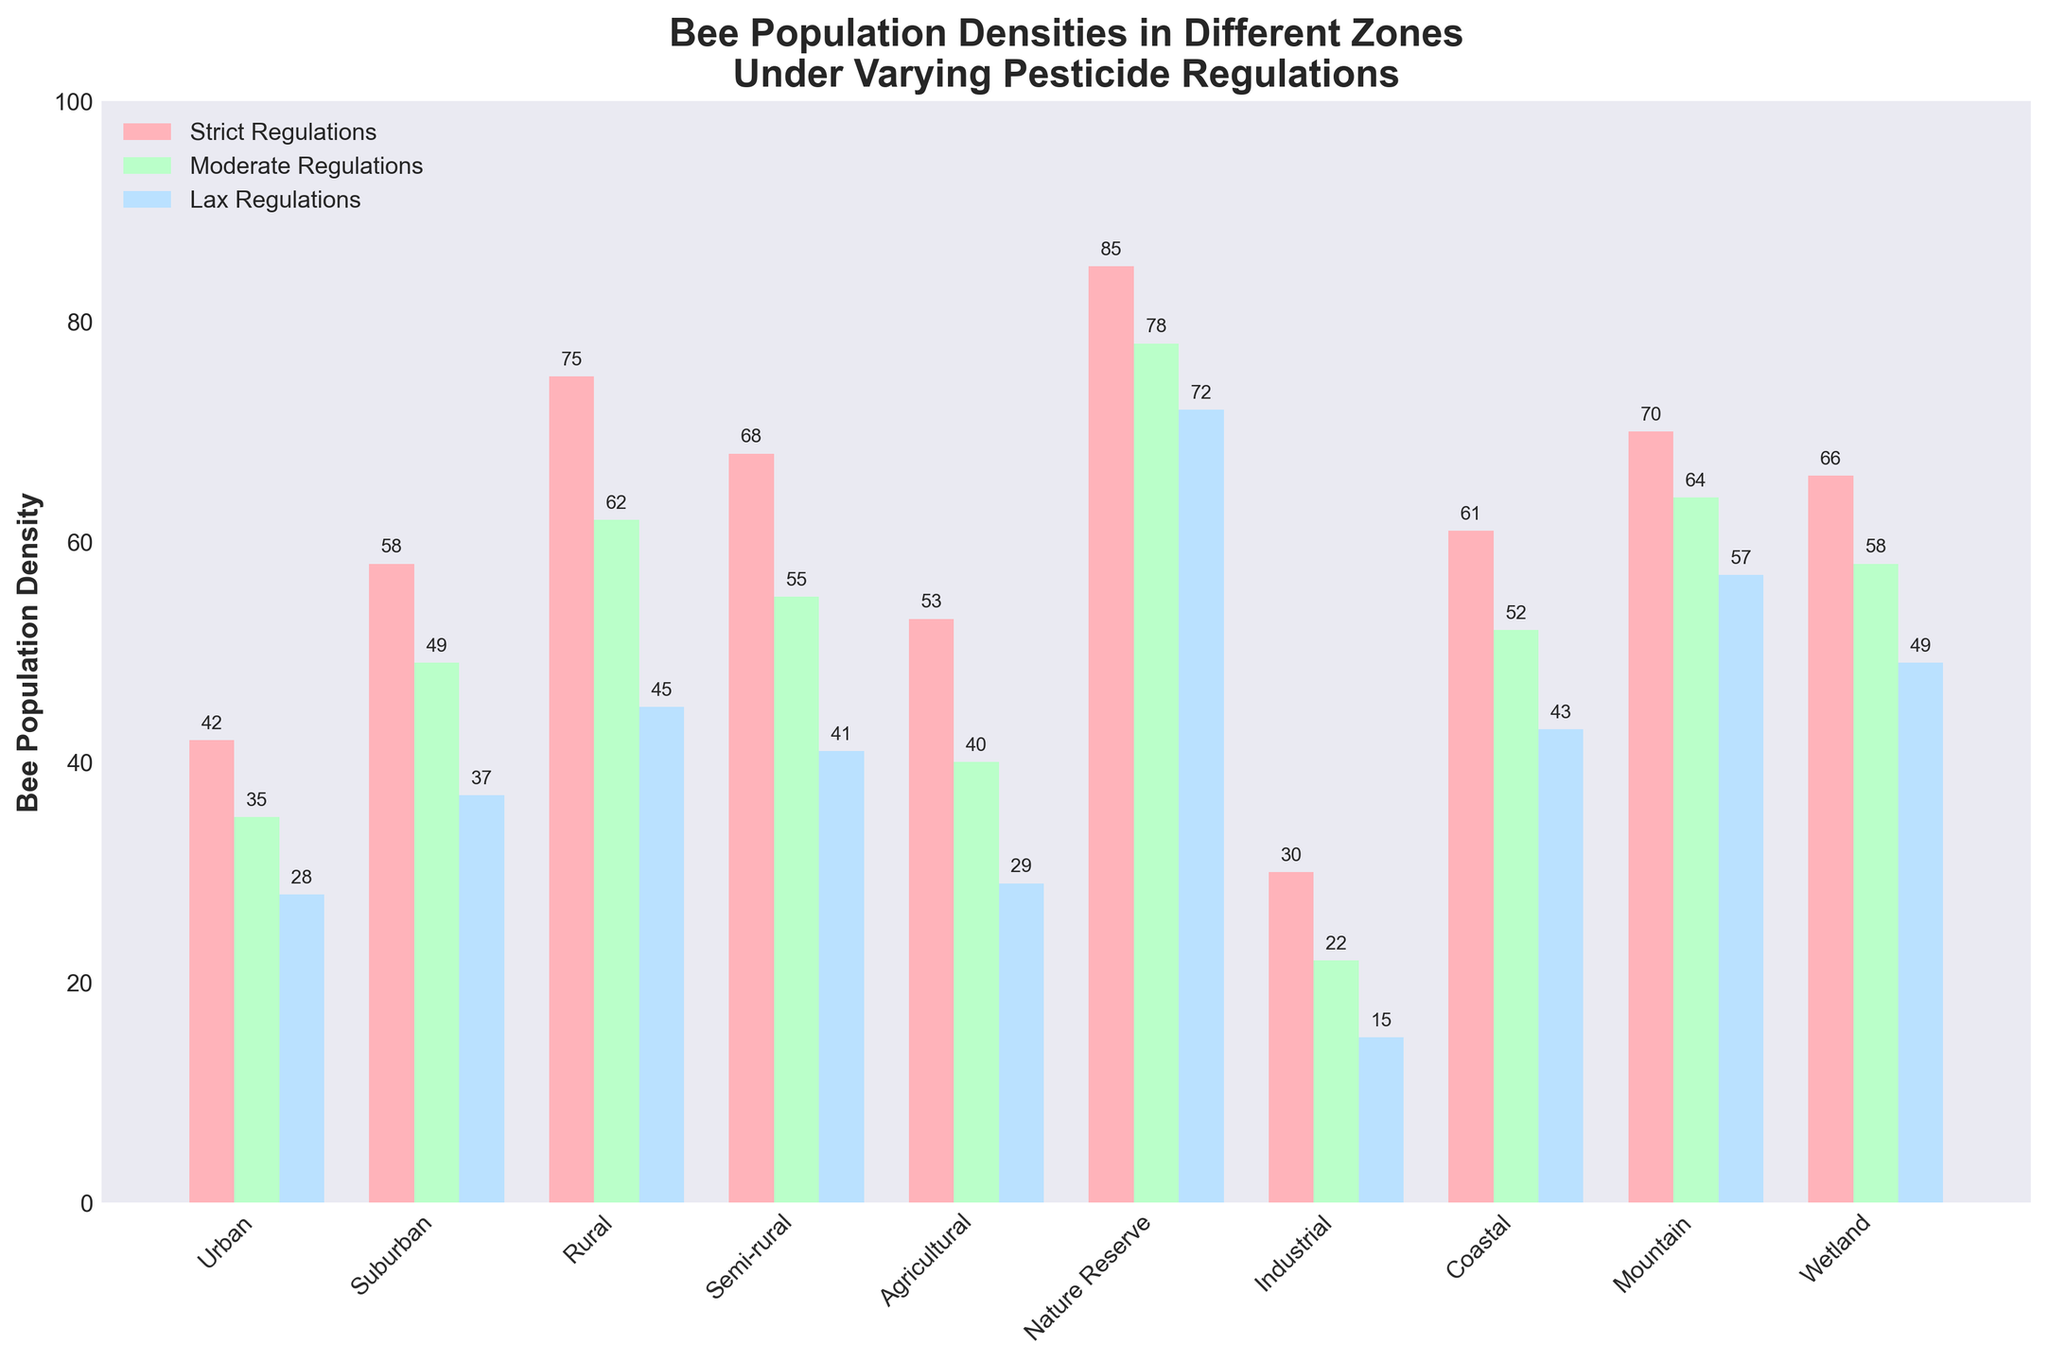What's the highest bee population density among all zones for each regulation level? By examining the bar chart, identify the tallest bars in each of the three categories: Strict Regulations, Moderate Regulations, and Lax Regulations. The highest densities are 85 (Nature Reserve), 78 (Nature Reserve), and 72 (Nature Reserve) respectively.
Answer: 85, 78, 72 Which zone has the lowest bee population density for Lax Regulations? Look at the bars corresponding to Lax Regulations for all zones and find the shortest one. The Industrial zone has the shortest bar, indicating the lowest density.
Answer: Industrial How much higher is the bee population density in Rural zones under Strict Regulations compared to Moderate Regulations? Subtract the bee population density under Moderate Regulations from that under Strict Regulations in Rural zones: 75 (Strict) - 62 (Moderate) = 13.
Answer: 13 Which two zones have almost the same bee population density under Moderate Regulations? Compare the heights of the bars in the Moderate Regulations category and find two zones with similar heights: Mountain and Wetland (64 and 58) are close, but Coastal and Wetland are closest (52 and 49).
Answer: Coastal and Wetland What is the average bee population density for Urban zones across all regulation levels? Sum the densities across the three regulation levels and divide by 3: (42 + 35 + 28) / 3 = 35.
Answer: 35 For which regulation level do Industrial zones have the largest difference in bee population density compared to Nature Reserves? Calculate the difference in bee population density between Nature Reserves and Industrial zones for each regulation level. The differences are 85-30=55 (Strict), 78-22=56 (Moderate), and 72-15=57 (Lax). The largest difference is 57 under Lax Regulations.
Answer: Lax Regulations How does the bee population density in Suburban zones with Lax Regulations compare to Industrial zones with Moderate Regulations? Compare the densities by looking at the heights of the corresponding bars: Suburban (Lax) has 37 and Industrial (Moderate) has 22. Therefore, Suburban's density is higher.
Answer: Suburban (Lax) > Industrial (Moderate) Is there any zone where bee population density is consistently high across all regulation levels? By evaluating the heights of the bars for Strict, Moderate, and Lax Regulations, Nature Reserve consistently has high densities across all levels: 85, 78, and 72.
Answer: Nature Reserve Which regulation level shows the greatest variability in bee population density across all zones? To determine this, observe each group's range (max - min). Strict: 85-30=55, Moderate: 78-22=56, Lax: 72-15=57. The greatest variability is in Lax Regulations with a range of 57.
Answer: Lax Regulations What is the total bee population density for Semi-rural zones across all regulation levels? Add the densities for Semi-rural zones under each regulation level: 68 (Strict) + 55 (Moderate) + 41 (Lax) = 164.
Answer: 164 